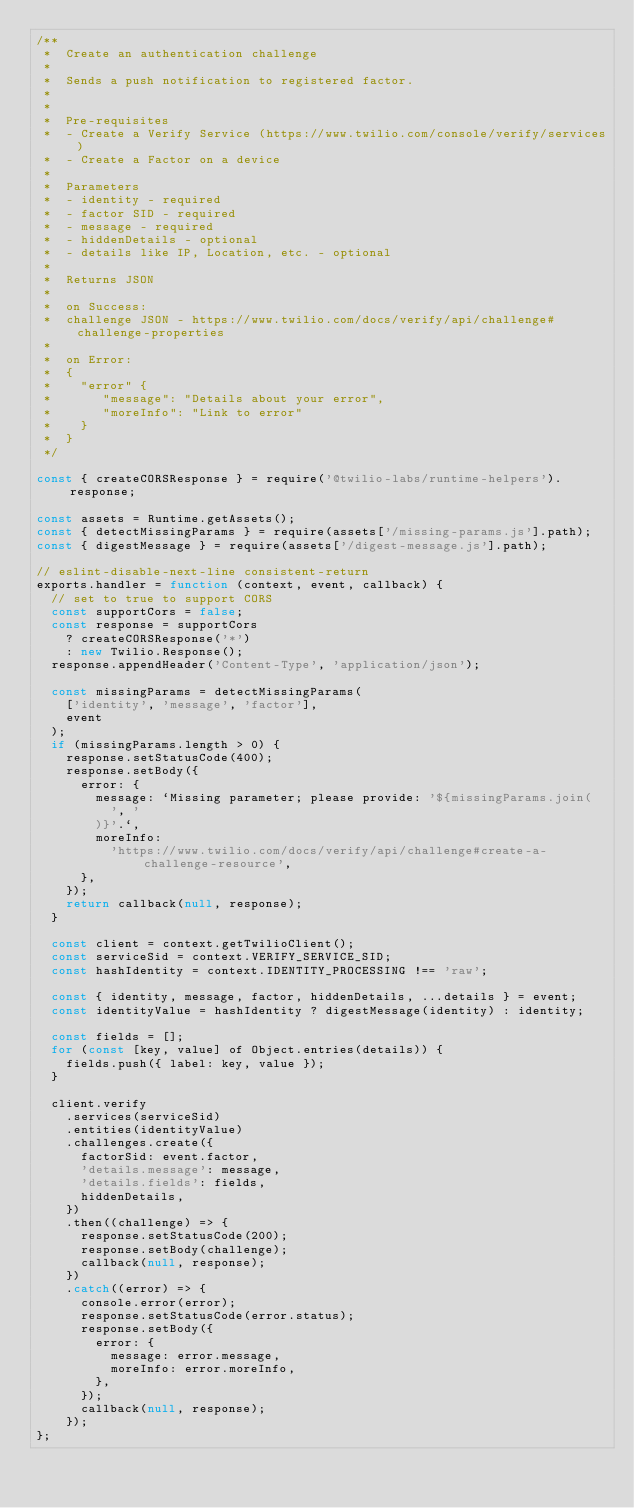<code> <loc_0><loc_0><loc_500><loc_500><_JavaScript_>/**
 *  Create an authentication challenge
 *
 *  Sends a push notification to registered factor.
 *
 *
 *  Pre-requisites
 *  - Create a Verify Service (https://www.twilio.com/console/verify/services)
 *  - Create a Factor on a device
 *
 *  Parameters
 *  - identity - required
 *  - factor SID - required
 *  - message - required
 *  - hiddenDetails - optional
 *  - details like IP, Location, etc. - optional
 *
 *  Returns JSON
 *
 *  on Success:
 *  challenge JSON - https://www.twilio.com/docs/verify/api/challenge#challenge-properties
 *
 *  on Error:
 *  {
 *    "error" {
 *       "message": "Details about your error",
 *       "moreInfo": "Link to error"
 *    }
 *  }
 */

const { createCORSResponse } = require('@twilio-labs/runtime-helpers').response;

const assets = Runtime.getAssets();
const { detectMissingParams } = require(assets['/missing-params.js'].path);
const { digestMessage } = require(assets['/digest-message.js'].path);

// eslint-disable-next-line consistent-return
exports.handler = function (context, event, callback) {
  // set to true to support CORS
  const supportCors = false;
  const response = supportCors
    ? createCORSResponse('*')
    : new Twilio.Response();
  response.appendHeader('Content-Type', 'application/json');

  const missingParams = detectMissingParams(
    ['identity', 'message', 'factor'],
    event
  );
  if (missingParams.length > 0) {
    response.setStatusCode(400);
    response.setBody({
      error: {
        message: `Missing parameter; please provide: '${missingParams.join(
          ', '
        )}'.`,
        moreInfo:
          'https://www.twilio.com/docs/verify/api/challenge#create-a-challenge-resource',
      },
    });
    return callback(null, response);
  }

  const client = context.getTwilioClient();
  const serviceSid = context.VERIFY_SERVICE_SID;
  const hashIdentity = context.IDENTITY_PROCESSING !== 'raw';

  const { identity, message, factor, hiddenDetails, ...details } = event;
  const identityValue = hashIdentity ? digestMessage(identity) : identity;

  const fields = [];
  for (const [key, value] of Object.entries(details)) {
    fields.push({ label: key, value });
  }

  client.verify
    .services(serviceSid)
    .entities(identityValue)
    .challenges.create({
      factorSid: event.factor,
      'details.message': message,
      'details.fields': fields,
      hiddenDetails,
    })
    .then((challenge) => {
      response.setStatusCode(200);
      response.setBody(challenge);
      callback(null, response);
    })
    .catch((error) => {
      console.error(error);
      response.setStatusCode(error.status);
      response.setBody({
        error: {
          message: error.message,
          moreInfo: error.moreInfo,
        },
      });
      callback(null, response);
    });
};
</code> 